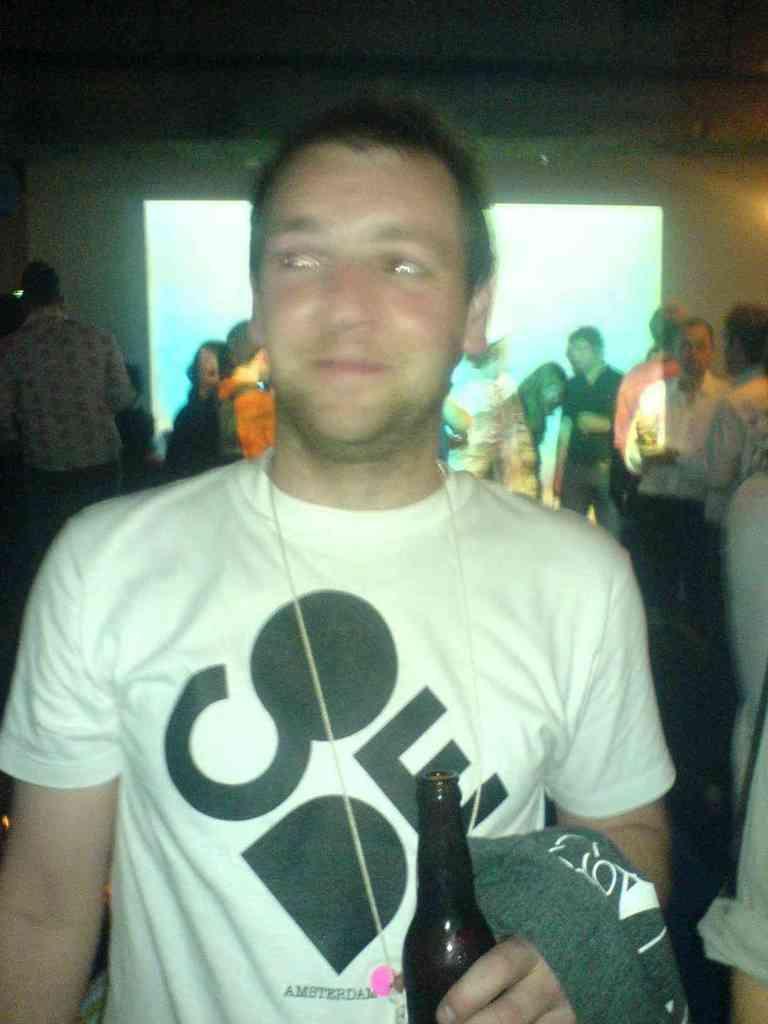How would you summarize this image in a sentence or two? In this picture we can see man smiling holding bottle in his hand and in background we can see some more people standing and in background we can see banner, screen. 